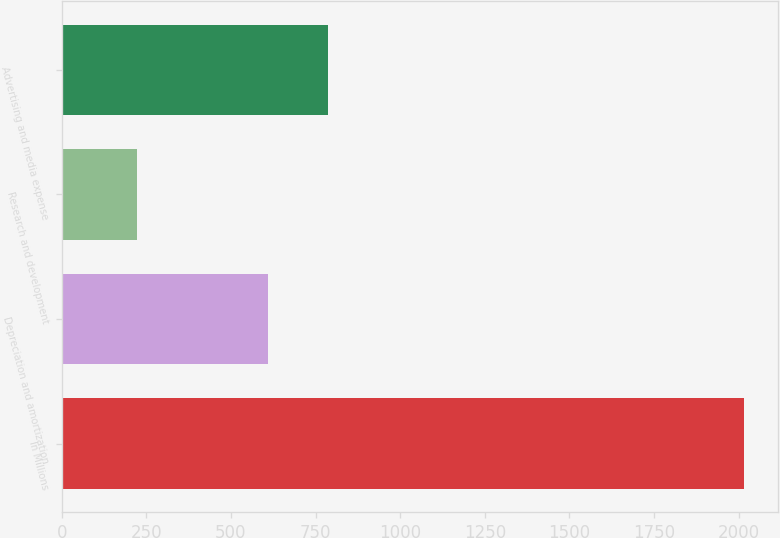Convert chart. <chart><loc_0><loc_0><loc_500><loc_500><bar_chart><fcel>In Millions<fcel>Depreciation and amortization<fcel>Research and development<fcel>Advertising and media expense<nl><fcel>2016<fcel>608.1<fcel>222.1<fcel>787.49<nl></chart> 